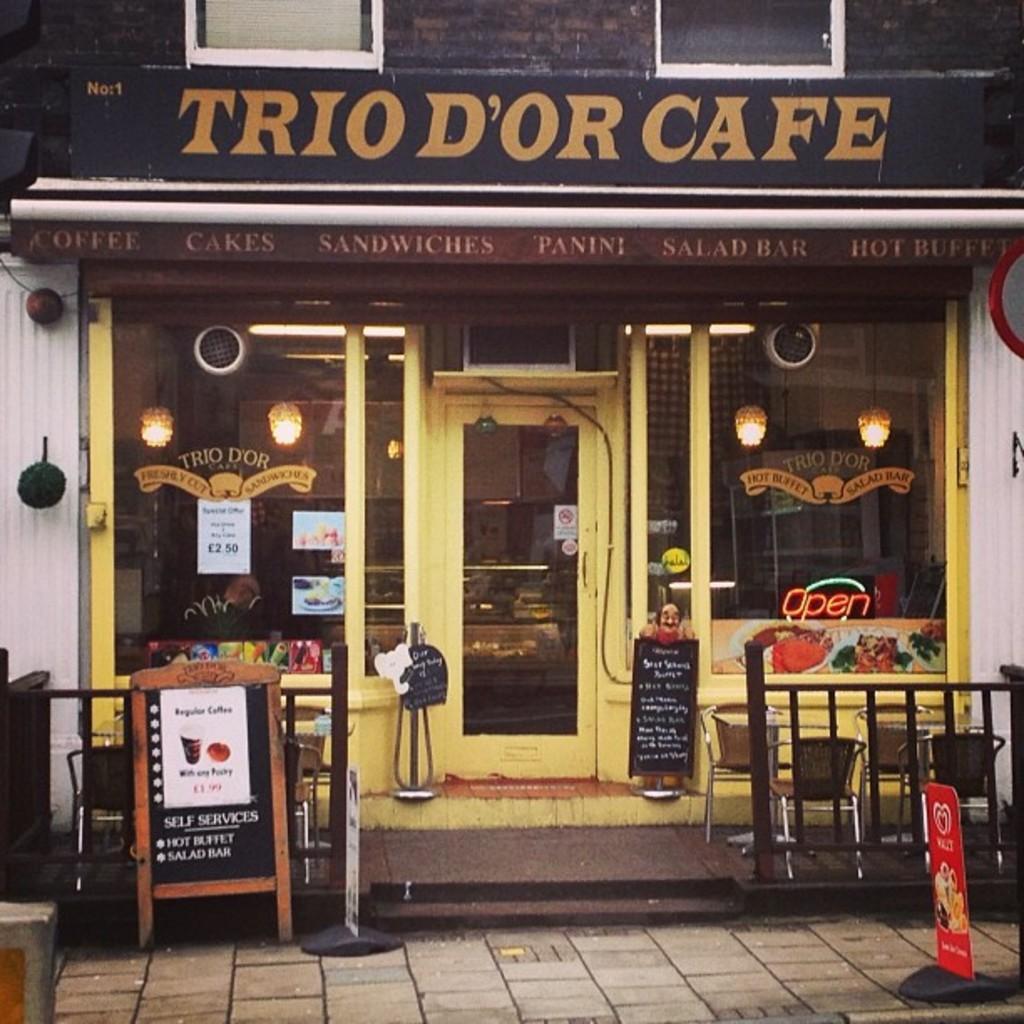Could you give a brief overview of what you see in this image? In this image, we can see chairs, grilles and boards and there is a stand. In the background, there is a building and we can see balls, glass doors and through the glass we can see screens, lights and some other objects and there are some posters. At the bottom, there is a road. 